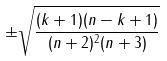Convert formula to latex. <formula><loc_0><loc_0><loc_500><loc_500>\pm \sqrt { \frac { ( k + 1 ) ( n - k + 1 ) } { ( n + 2 ) ^ { 2 } ( n + 3 ) } }</formula> 